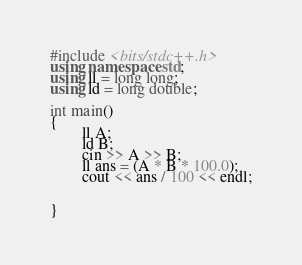<code> <loc_0><loc_0><loc_500><loc_500><_C++_>#include <bits/stdc++.h>
using namespace std;
using ll = long long;
using ld = long double;

int main()
{
        ll A;
        ld B;
        cin >> A >> B;
        ll ans = (A * B * 100.0);
        cout << ans / 100 << endl;


}
</code> 